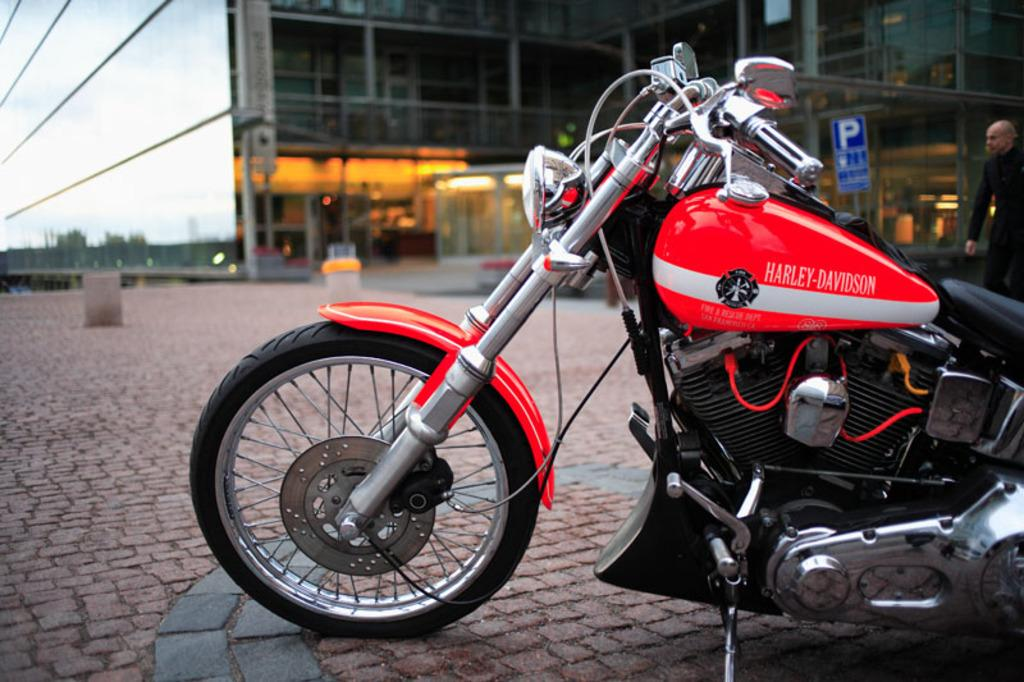What type of vehicle is in the image? There is a red Harley Davidson bike in the image. Where is the bike located in the image? The bike is in the right corner of the image. What can be seen in the background of the image? There is a building in the background of the image. What type of cheese is on the plate in the image? There is no cheese or plate present in the image; it features a red Harley Davidson bike and a building in the background. 